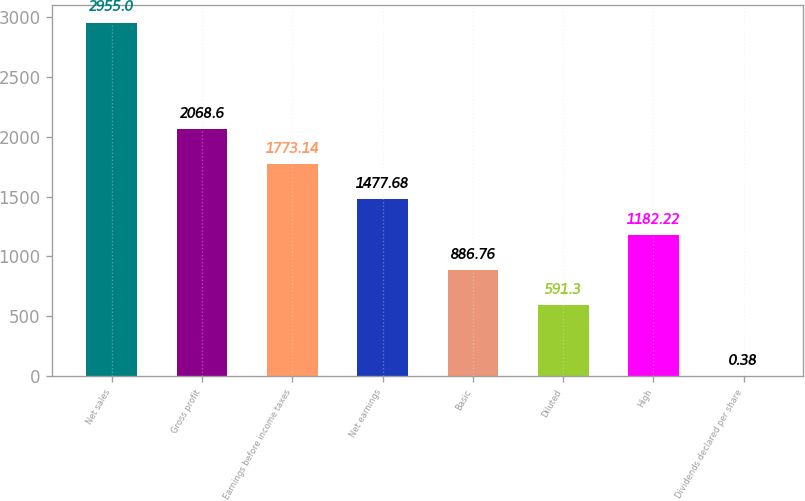Convert chart. <chart><loc_0><loc_0><loc_500><loc_500><bar_chart><fcel>Net sales<fcel>Gross profit<fcel>Earnings before income taxes<fcel>Net earnings<fcel>Basic<fcel>Diluted<fcel>High<fcel>Dividends declared per share<nl><fcel>2955<fcel>2068.6<fcel>1773.14<fcel>1477.68<fcel>886.76<fcel>591.3<fcel>1182.22<fcel>0.38<nl></chart> 